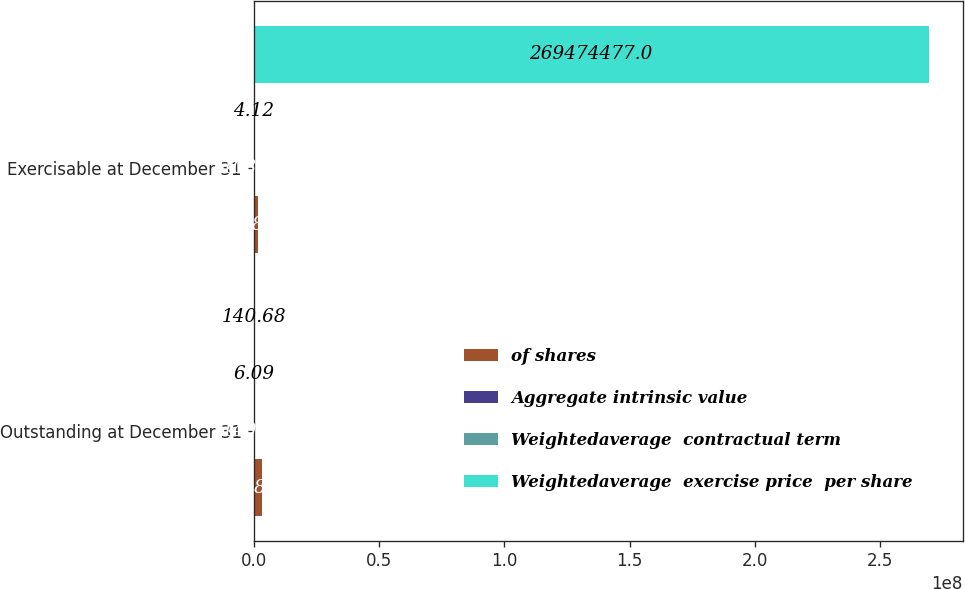Convert chart to OTSL. <chart><loc_0><loc_0><loc_500><loc_500><stacked_bar_chart><ecel><fcel>Outstanding at December 31<fcel>Exercisable at December 31<nl><fcel>of shares<fcel>3.19586e+06<fcel>1.76687e+06<nl><fcel>Aggregate intrinsic value<fcel>140.68<fcel>103.48<nl><fcel>Weightedaverage  contractual term<fcel>6.09<fcel>4.12<nl><fcel>Weightedaverage  exercise price  per share<fcel>140.68<fcel>2.69474e+08<nl></chart> 